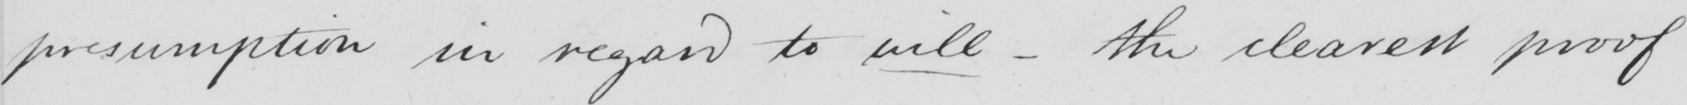Can you read and transcribe this handwriting? presumption in regard to will  _  the clearest proof 